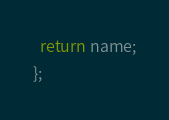Convert code to text. <code><loc_0><loc_0><loc_500><loc_500><_JavaScript_>  return name;
};
</code> 